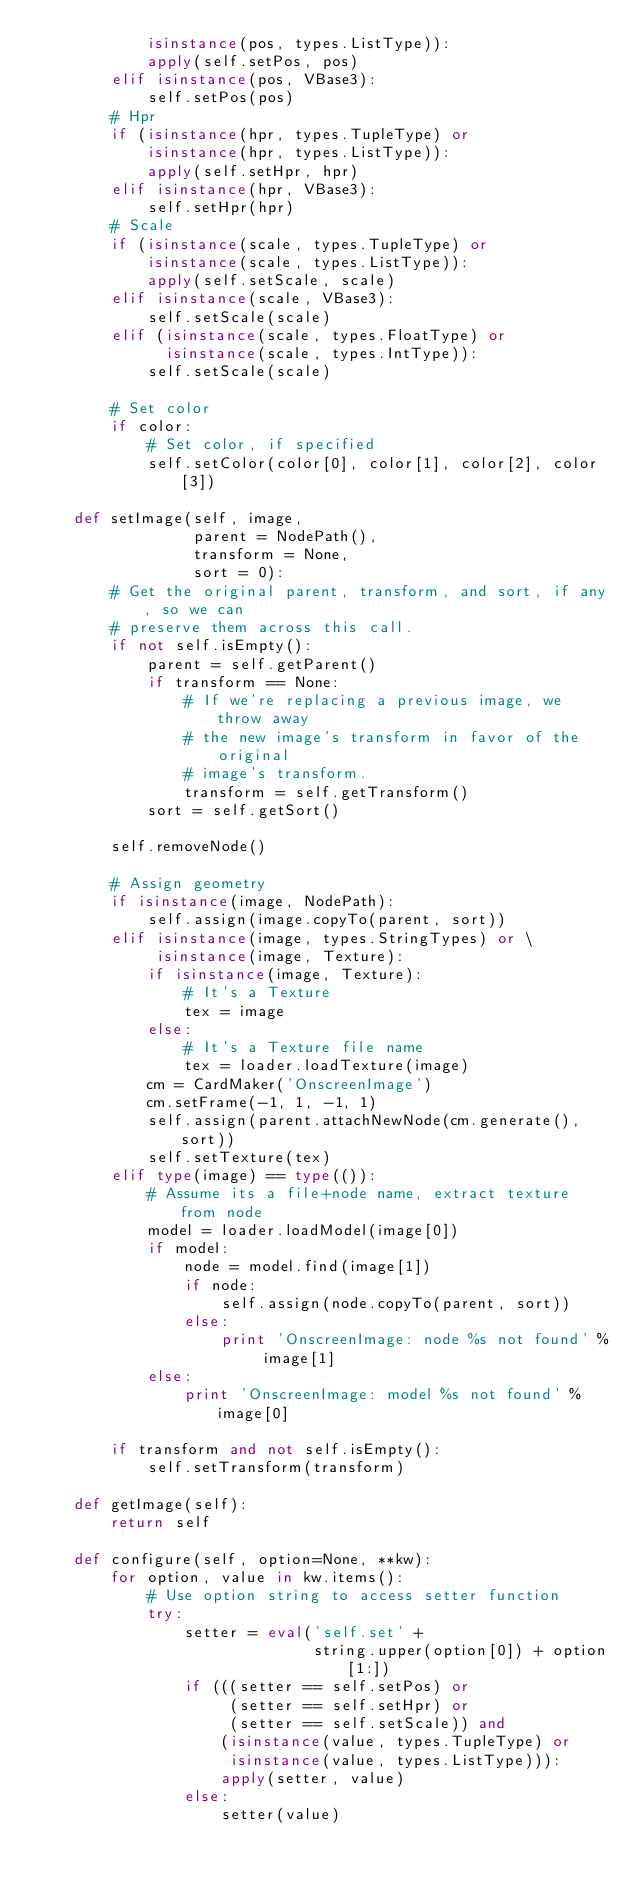Convert code to text. <code><loc_0><loc_0><loc_500><loc_500><_Python_>            isinstance(pos, types.ListType)):
            apply(self.setPos, pos)
        elif isinstance(pos, VBase3):
            self.setPos(pos)
        # Hpr
        if (isinstance(hpr, types.TupleType) or
            isinstance(hpr, types.ListType)):
            apply(self.setHpr, hpr)
        elif isinstance(hpr, VBase3):
            self.setHpr(hpr)
        # Scale
        if (isinstance(scale, types.TupleType) or
            isinstance(scale, types.ListType)):
            apply(self.setScale, scale)
        elif isinstance(scale, VBase3):
            self.setScale(scale)
        elif (isinstance(scale, types.FloatType) or
              isinstance(scale, types.IntType)):
            self.setScale(scale)

        # Set color
        if color:
            # Set color, if specified
            self.setColor(color[0], color[1], color[2], color[3])

    def setImage(self, image,
                 parent = NodePath(),
                 transform = None,
                 sort = 0):
        # Get the original parent, transform, and sort, if any, so we can
        # preserve them across this call.
        if not self.isEmpty():
            parent = self.getParent()
            if transform == None:
                # If we're replacing a previous image, we throw away
                # the new image's transform in favor of the original
                # image's transform.
                transform = self.getTransform()
            sort = self.getSort()

        self.removeNode()

        # Assign geometry
        if isinstance(image, NodePath):
            self.assign(image.copyTo(parent, sort))
        elif isinstance(image, types.StringTypes) or \
             isinstance(image, Texture):
            if isinstance(image, Texture):
                # It's a Texture
                tex = image
            else:
                # It's a Texture file name
                tex = loader.loadTexture(image)
            cm = CardMaker('OnscreenImage')
            cm.setFrame(-1, 1, -1, 1)
            self.assign(parent.attachNewNode(cm.generate(), sort))
            self.setTexture(tex)
        elif type(image) == type(()):
            # Assume its a file+node name, extract texture from node
            model = loader.loadModel(image[0])
            if model:
                node = model.find(image[1])
                if node:
                    self.assign(node.copyTo(parent, sort))
                else:
                    print 'OnscreenImage: node %s not found' % image[1]
            else:
                print 'OnscreenImage: model %s not found' % image[0]

        if transform and not self.isEmpty():
            self.setTransform(transform)

    def getImage(self):
        return self

    def configure(self, option=None, **kw):
        for option, value in kw.items():
            # Use option string to access setter function
            try:
                setter = eval('self.set' +
                              string.upper(option[0]) + option[1:])
                if (((setter == self.setPos) or
                     (setter == self.setHpr) or
                     (setter == self.setScale)) and
                    (isinstance(value, types.TupleType) or
                     isinstance(value, types.ListType))):
                    apply(setter, value)
                else:
                    setter(value)</code> 